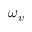Convert formula to latex. <formula><loc_0><loc_0><loc_500><loc_500>\omega _ { v }</formula> 